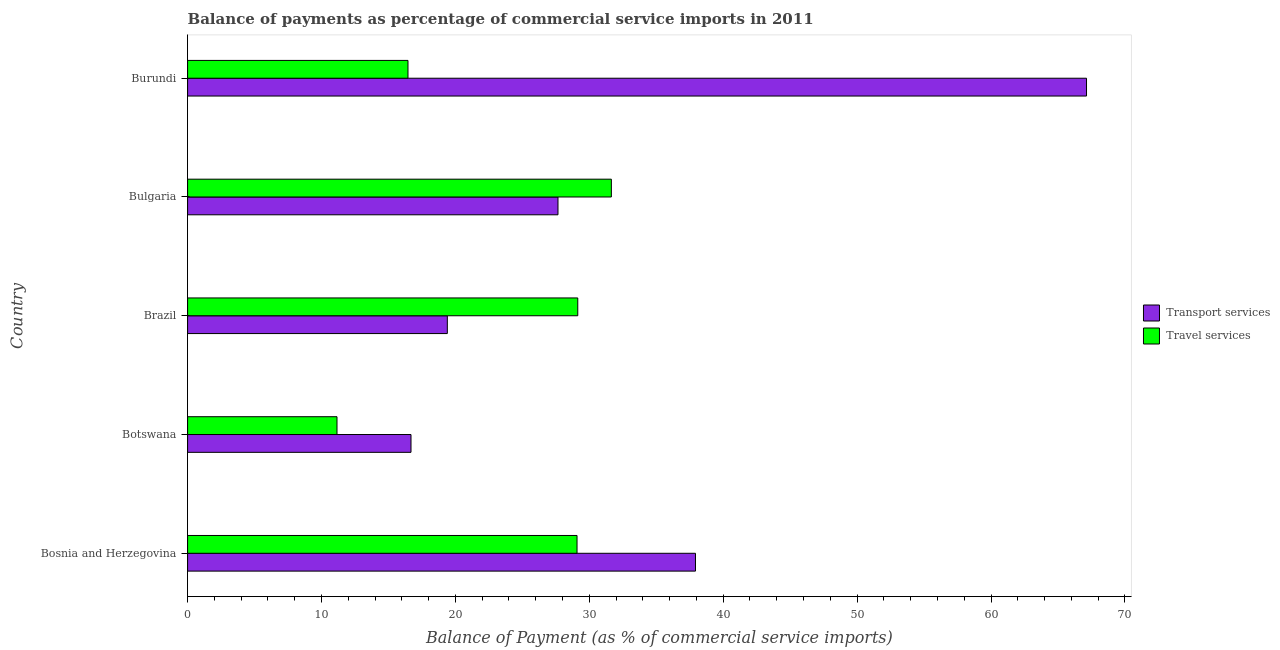How many different coloured bars are there?
Your answer should be very brief. 2. How many groups of bars are there?
Your response must be concise. 5. Are the number of bars per tick equal to the number of legend labels?
Offer a terse response. Yes. How many bars are there on the 4th tick from the bottom?
Your answer should be very brief. 2. What is the label of the 1st group of bars from the top?
Offer a terse response. Burundi. In how many cases, is the number of bars for a given country not equal to the number of legend labels?
Keep it short and to the point. 0. What is the balance of payments of travel services in Bosnia and Herzegovina?
Offer a very short reply. 29.08. Across all countries, what is the maximum balance of payments of travel services?
Keep it short and to the point. 31.65. Across all countries, what is the minimum balance of payments of transport services?
Offer a terse response. 16.68. In which country was the balance of payments of travel services maximum?
Provide a succinct answer. Bulgaria. In which country was the balance of payments of travel services minimum?
Your answer should be very brief. Botswana. What is the total balance of payments of transport services in the graph?
Keep it short and to the point. 168.8. What is the difference between the balance of payments of transport services in Brazil and that in Bulgaria?
Offer a terse response. -8.27. What is the difference between the balance of payments of travel services in Botswana and the balance of payments of transport services in Brazil?
Provide a short and direct response. -8.24. What is the average balance of payments of transport services per country?
Give a very brief answer. 33.76. What is the difference between the balance of payments of transport services and balance of payments of travel services in Burundi?
Your answer should be very brief. 50.67. What is the ratio of the balance of payments of transport services in Bosnia and Herzegovina to that in Burundi?
Provide a short and direct response. 0.56. What is the difference between the highest and the second highest balance of payments of transport services?
Offer a very short reply. 29.2. What is the difference between the highest and the lowest balance of payments of travel services?
Offer a terse response. 20.49. What does the 2nd bar from the top in Brazil represents?
Your answer should be very brief. Transport services. What does the 1st bar from the bottom in Brazil represents?
Provide a succinct answer. Transport services. Are the values on the major ticks of X-axis written in scientific E-notation?
Make the answer very short. No. Does the graph contain any zero values?
Your response must be concise. No. How are the legend labels stacked?
Your answer should be compact. Vertical. What is the title of the graph?
Your response must be concise. Balance of payments as percentage of commercial service imports in 2011. What is the label or title of the X-axis?
Make the answer very short. Balance of Payment (as % of commercial service imports). What is the Balance of Payment (as % of commercial service imports) of Transport services in Bosnia and Herzegovina?
Your answer should be very brief. 37.93. What is the Balance of Payment (as % of commercial service imports) in Travel services in Bosnia and Herzegovina?
Your answer should be compact. 29.08. What is the Balance of Payment (as % of commercial service imports) in Transport services in Botswana?
Offer a very short reply. 16.68. What is the Balance of Payment (as % of commercial service imports) of Travel services in Botswana?
Your answer should be compact. 11.16. What is the Balance of Payment (as % of commercial service imports) in Transport services in Brazil?
Ensure brevity in your answer.  19.4. What is the Balance of Payment (as % of commercial service imports) of Travel services in Brazil?
Give a very brief answer. 29.14. What is the Balance of Payment (as % of commercial service imports) of Transport services in Bulgaria?
Provide a short and direct response. 27.66. What is the Balance of Payment (as % of commercial service imports) in Travel services in Bulgaria?
Offer a very short reply. 31.65. What is the Balance of Payment (as % of commercial service imports) in Transport services in Burundi?
Your response must be concise. 67.13. What is the Balance of Payment (as % of commercial service imports) in Travel services in Burundi?
Give a very brief answer. 16.46. Across all countries, what is the maximum Balance of Payment (as % of commercial service imports) in Transport services?
Provide a short and direct response. 67.13. Across all countries, what is the maximum Balance of Payment (as % of commercial service imports) of Travel services?
Offer a very short reply. 31.65. Across all countries, what is the minimum Balance of Payment (as % of commercial service imports) of Transport services?
Make the answer very short. 16.68. Across all countries, what is the minimum Balance of Payment (as % of commercial service imports) of Travel services?
Offer a very short reply. 11.16. What is the total Balance of Payment (as % of commercial service imports) of Transport services in the graph?
Provide a succinct answer. 168.8. What is the total Balance of Payment (as % of commercial service imports) of Travel services in the graph?
Offer a terse response. 117.49. What is the difference between the Balance of Payment (as % of commercial service imports) of Transport services in Bosnia and Herzegovina and that in Botswana?
Your response must be concise. 21.24. What is the difference between the Balance of Payment (as % of commercial service imports) of Travel services in Bosnia and Herzegovina and that in Botswana?
Provide a short and direct response. 17.93. What is the difference between the Balance of Payment (as % of commercial service imports) in Transport services in Bosnia and Herzegovina and that in Brazil?
Provide a short and direct response. 18.53. What is the difference between the Balance of Payment (as % of commercial service imports) in Travel services in Bosnia and Herzegovina and that in Brazil?
Offer a terse response. -0.06. What is the difference between the Balance of Payment (as % of commercial service imports) in Transport services in Bosnia and Herzegovina and that in Bulgaria?
Offer a terse response. 10.27. What is the difference between the Balance of Payment (as % of commercial service imports) in Travel services in Bosnia and Herzegovina and that in Bulgaria?
Provide a succinct answer. -2.56. What is the difference between the Balance of Payment (as % of commercial service imports) in Transport services in Bosnia and Herzegovina and that in Burundi?
Offer a very short reply. -29.2. What is the difference between the Balance of Payment (as % of commercial service imports) in Travel services in Bosnia and Herzegovina and that in Burundi?
Make the answer very short. 12.62. What is the difference between the Balance of Payment (as % of commercial service imports) of Transport services in Botswana and that in Brazil?
Provide a succinct answer. -2.71. What is the difference between the Balance of Payment (as % of commercial service imports) of Travel services in Botswana and that in Brazil?
Offer a terse response. -17.98. What is the difference between the Balance of Payment (as % of commercial service imports) of Transport services in Botswana and that in Bulgaria?
Ensure brevity in your answer.  -10.98. What is the difference between the Balance of Payment (as % of commercial service imports) in Travel services in Botswana and that in Bulgaria?
Ensure brevity in your answer.  -20.49. What is the difference between the Balance of Payment (as % of commercial service imports) of Transport services in Botswana and that in Burundi?
Give a very brief answer. -50.45. What is the difference between the Balance of Payment (as % of commercial service imports) in Travel services in Botswana and that in Burundi?
Offer a very short reply. -5.3. What is the difference between the Balance of Payment (as % of commercial service imports) in Transport services in Brazil and that in Bulgaria?
Offer a terse response. -8.26. What is the difference between the Balance of Payment (as % of commercial service imports) of Travel services in Brazil and that in Bulgaria?
Your answer should be very brief. -2.51. What is the difference between the Balance of Payment (as % of commercial service imports) of Transport services in Brazil and that in Burundi?
Your answer should be very brief. -47.74. What is the difference between the Balance of Payment (as % of commercial service imports) in Travel services in Brazil and that in Burundi?
Your response must be concise. 12.68. What is the difference between the Balance of Payment (as % of commercial service imports) of Transport services in Bulgaria and that in Burundi?
Give a very brief answer. -39.47. What is the difference between the Balance of Payment (as % of commercial service imports) in Travel services in Bulgaria and that in Burundi?
Offer a very short reply. 15.19. What is the difference between the Balance of Payment (as % of commercial service imports) of Transport services in Bosnia and Herzegovina and the Balance of Payment (as % of commercial service imports) of Travel services in Botswana?
Provide a short and direct response. 26.77. What is the difference between the Balance of Payment (as % of commercial service imports) of Transport services in Bosnia and Herzegovina and the Balance of Payment (as % of commercial service imports) of Travel services in Brazil?
Ensure brevity in your answer.  8.79. What is the difference between the Balance of Payment (as % of commercial service imports) of Transport services in Bosnia and Herzegovina and the Balance of Payment (as % of commercial service imports) of Travel services in Bulgaria?
Provide a short and direct response. 6.28. What is the difference between the Balance of Payment (as % of commercial service imports) of Transport services in Bosnia and Herzegovina and the Balance of Payment (as % of commercial service imports) of Travel services in Burundi?
Your answer should be compact. 21.47. What is the difference between the Balance of Payment (as % of commercial service imports) in Transport services in Botswana and the Balance of Payment (as % of commercial service imports) in Travel services in Brazil?
Provide a short and direct response. -12.45. What is the difference between the Balance of Payment (as % of commercial service imports) of Transport services in Botswana and the Balance of Payment (as % of commercial service imports) of Travel services in Bulgaria?
Provide a short and direct response. -14.96. What is the difference between the Balance of Payment (as % of commercial service imports) in Transport services in Botswana and the Balance of Payment (as % of commercial service imports) in Travel services in Burundi?
Make the answer very short. 0.23. What is the difference between the Balance of Payment (as % of commercial service imports) of Transport services in Brazil and the Balance of Payment (as % of commercial service imports) of Travel services in Bulgaria?
Your answer should be very brief. -12.25. What is the difference between the Balance of Payment (as % of commercial service imports) of Transport services in Brazil and the Balance of Payment (as % of commercial service imports) of Travel services in Burundi?
Ensure brevity in your answer.  2.94. What is the difference between the Balance of Payment (as % of commercial service imports) in Transport services in Bulgaria and the Balance of Payment (as % of commercial service imports) in Travel services in Burundi?
Your response must be concise. 11.2. What is the average Balance of Payment (as % of commercial service imports) in Transport services per country?
Provide a succinct answer. 33.76. What is the average Balance of Payment (as % of commercial service imports) in Travel services per country?
Offer a terse response. 23.5. What is the difference between the Balance of Payment (as % of commercial service imports) in Transport services and Balance of Payment (as % of commercial service imports) in Travel services in Bosnia and Herzegovina?
Make the answer very short. 8.85. What is the difference between the Balance of Payment (as % of commercial service imports) in Transport services and Balance of Payment (as % of commercial service imports) in Travel services in Botswana?
Offer a terse response. 5.53. What is the difference between the Balance of Payment (as % of commercial service imports) of Transport services and Balance of Payment (as % of commercial service imports) of Travel services in Brazil?
Your response must be concise. -9.74. What is the difference between the Balance of Payment (as % of commercial service imports) of Transport services and Balance of Payment (as % of commercial service imports) of Travel services in Bulgaria?
Provide a short and direct response. -3.99. What is the difference between the Balance of Payment (as % of commercial service imports) in Transport services and Balance of Payment (as % of commercial service imports) in Travel services in Burundi?
Give a very brief answer. 50.67. What is the ratio of the Balance of Payment (as % of commercial service imports) in Transport services in Bosnia and Herzegovina to that in Botswana?
Your response must be concise. 2.27. What is the ratio of the Balance of Payment (as % of commercial service imports) of Travel services in Bosnia and Herzegovina to that in Botswana?
Provide a short and direct response. 2.61. What is the ratio of the Balance of Payment (as % of commercial service imports) in Transport services in Bosnia and Herzegovina to that in Brazil?
Provide a short and direct response. 1.96. What is the ratio of the Balance of Payment (as % of commercial service imports) of Transport services in Bosnia and Herzegovina to that in Bulgaria?
Give a very brief answer. 1.37. What is the ratio of the Balance of Payment (as % of commercial service imports) of Travel services in Bosnia and Herzegovina to that in Bulgaria?
Provide a succinct answer. 0.92. What is the ratio of the Balance of Payment (as % of commercial service imports) of Transport services in Bosnia and Herzegovina to that in Burundi?
Provide a short and direct response. 0.56. What is the ratio of the Balance of Payment (as % of commercial service imports) of Travel services in Bosnia and Herzegovina to that in Burundi?
Offer a terse response. 1.77. What is the ratio of the Balance of Payment (as % of commercial service imports) in Transport services in Botswana to that in Brazil?
Give a very brief answer. 0.86. What is the ratio of the Balance of Payment (as % of commercial service imports) in Travel services in Botswana to that in Brazil?
Make the answer very short. 0.38. What is the ratio of the Balance of Payment (as % of commercial service imports) in Transport services in Botswana to that in Bulgaria?
Make the answer very short. 0.6. What is the ratio of the Balance of Payment (as % of commercial service imports) in Travel services in Botswana to that in Bulgaria?
Your response must be concise. 0.35. What is the ratio of the Balance of Payment (as % of commercial service imports) of Transport services in Botswana to that in Burundi?
Ensure brevity in your answer.  0.25. What is the ratio of the Balance of Payment (as % of commercial service imports) in Travel services in Botswana to that in Burundi?
Ensure brevity in your answer.  0.68. What is the ratio of the Balance of Payment (as % of commercial service imports) of Transport services in Brazil to that in Bulgaria?
Offer a very short reply. 0.7. What is the ratio of the Balance of Payment (as % of commercial service imports) in Travel services in Brazil to that in Bulgaria?
Keep it short and to the point. 0.92. What is the ratio of the Balance of Payment (as % of commercial service imports) in Transport services in Brazil to that in Burundi?
Offer a terse response. 0.29. What is the ratio of the Balance of Payment (as % of commercial service imports) of Travel services in Brazil to that in Burundi?
Your response must be concise. 1.77. What is the ratio of the Balance of Payment (as % of commercial service imports) of Transport services in Bulgaria to that in Burundi?
Give a very brief answer. 0.41. What is the ratio of the Balance of Payment (as % of commercial service imports) in Travel services in Bulgaria to that in Burundi?
Provide a short and direct response. 1.92. What is the difference between the highest and the second highest Balance of Payment (as % of commercial service imports) in Transport services?
Make the answer very short. 29.2. What is the difference between the highest and the second highest Balance of Payment (as % of commercial service imports) of Travel services?
Your answer should be very brief. 2.51. What is the difference between the highest and the lowest Balance of Payment (as % of commercial service imports) in Transport services?
Your answer should be compact. 50.45. What is the difference between the highest and the lowest Balance of Payment (as % of commercial service imports) in Travel services?
Your answer should be compact. 20.49. 